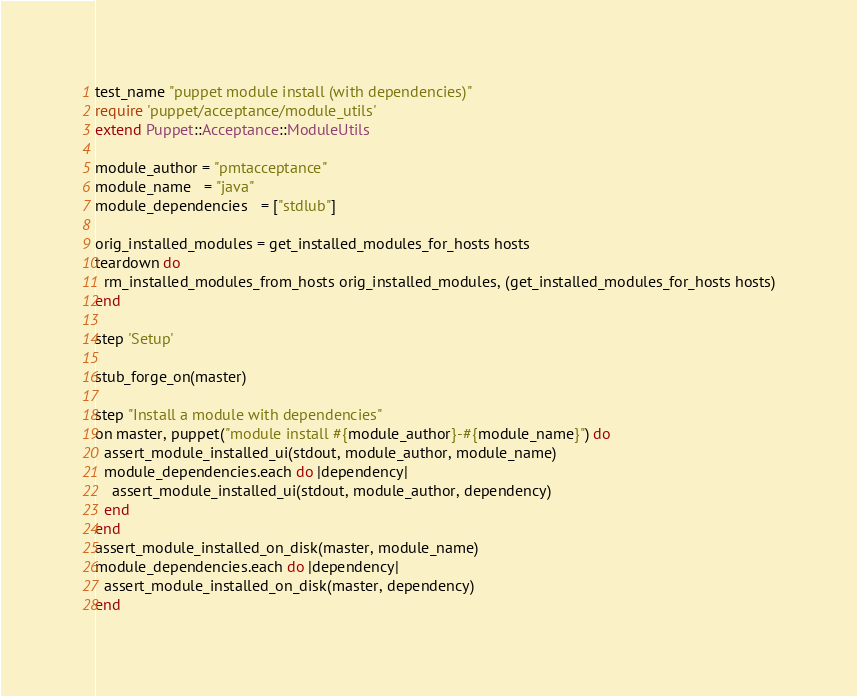Convert code to text. <code><loc_0><loc_0><loc_500><loc_500><_Ruby_>test_name "puppet module install (with dependencies)"
require 'puppet/acceptance/module_utils'
extend Puppet::Acceptance::ModuleUtils

module_author = "pmtacceptance"
module_name   = "java"
module_dependencies   = ["stdlub"]

orig_installed_modules = get_installed_modules_for_hosts hosts
teardown do
  rm_installed_modules_from_hosts orig_installed_modules, (get_installed_modules_for_hosts hosts)
end

step 'Setup'

stub_forge_on(master)

step "Install a module with dependencies"
on master, puppet("module install #{module_author}-#{module_name}") do
  assert_module_installed_ui(stdout, module_author, module_name)
  module_dependencies.each do |dependency|
    assert_module_installed_ui(stdout, module_author, dependency)
  end
end
assert_module_installed_on_disk(master, module_name)
module_dependencies.each do |dependency|
  assert_module_installed_on_disk(master, dependency)
end
</code> 